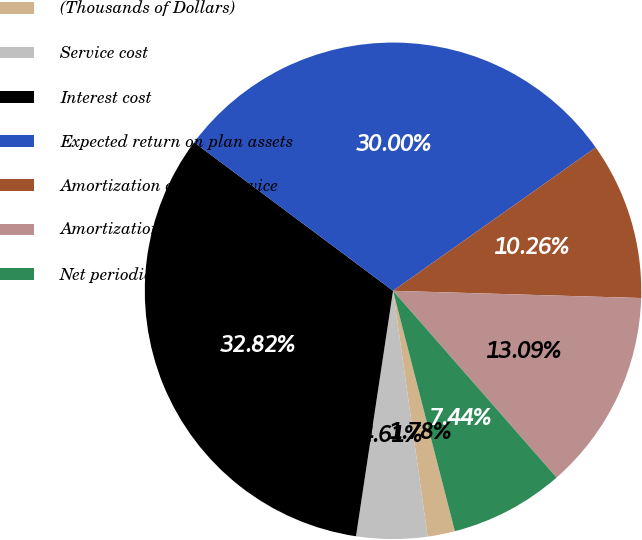Convert chart to OTSL. <chart><loc_0><loc_0><loc_500><loc_500><pie_chart><fcel>(Thousands of Dollars)<fcel>Service cost<fcel>Interest cost<fcel>Expected return on plan assets<fcel>Amortization of prior service<fcel>Amortization of net loss<fcel>Net periodic postretirement<nl><fcel>1.78%<fcel>4.61%<fcel>32.82%<fcel>30.0%<fcel>10.26%<fcel>13.09%<fcel>7.44%<nl></chart> 